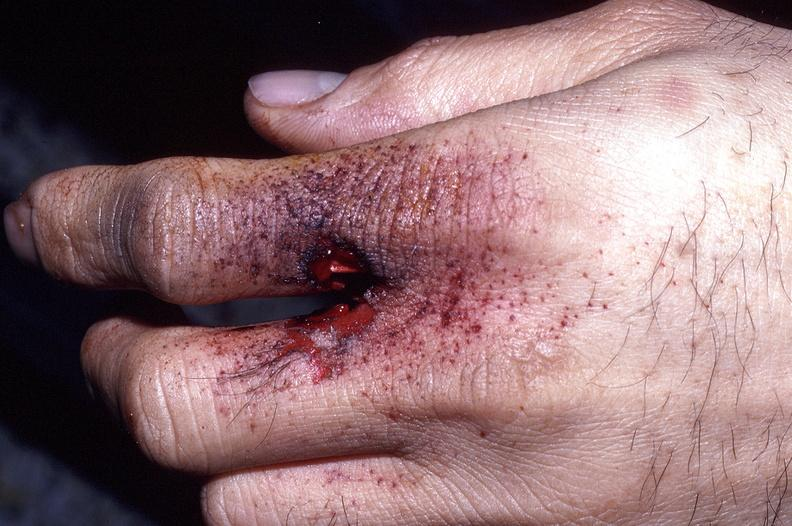does this image show hand, gunshot entrance wound, intermediate range, powder burns freckling?
Answer the question using a single word or phrase. Yes 